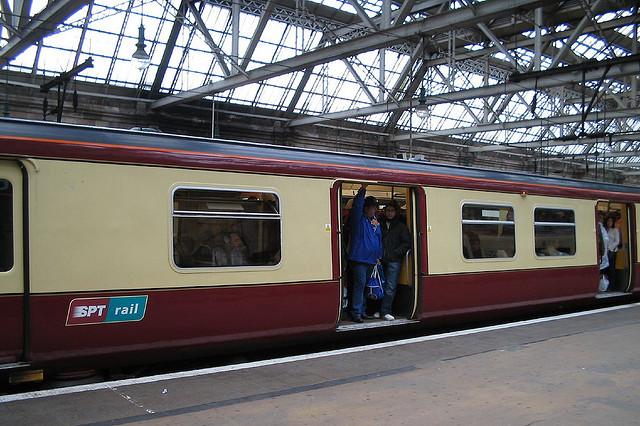Are the doors open?
Answer briefly. Yes. What rail line is this?
Write a very short answer. Spt. How many people are depicted?
Short answer required. 4. 